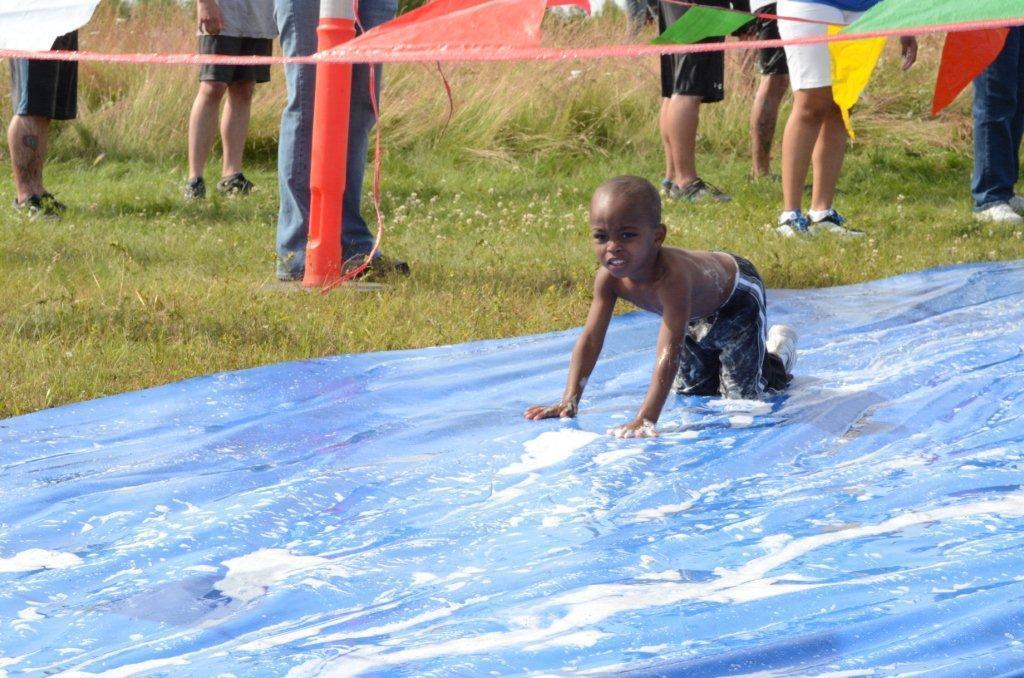Describe this image in one or two sentences. In this picture we can see a kid in the front, at the bottom there is a cover and water, there are some people standing in the background, there is grass in the middle, we can see ribbons at the top of the picture. 